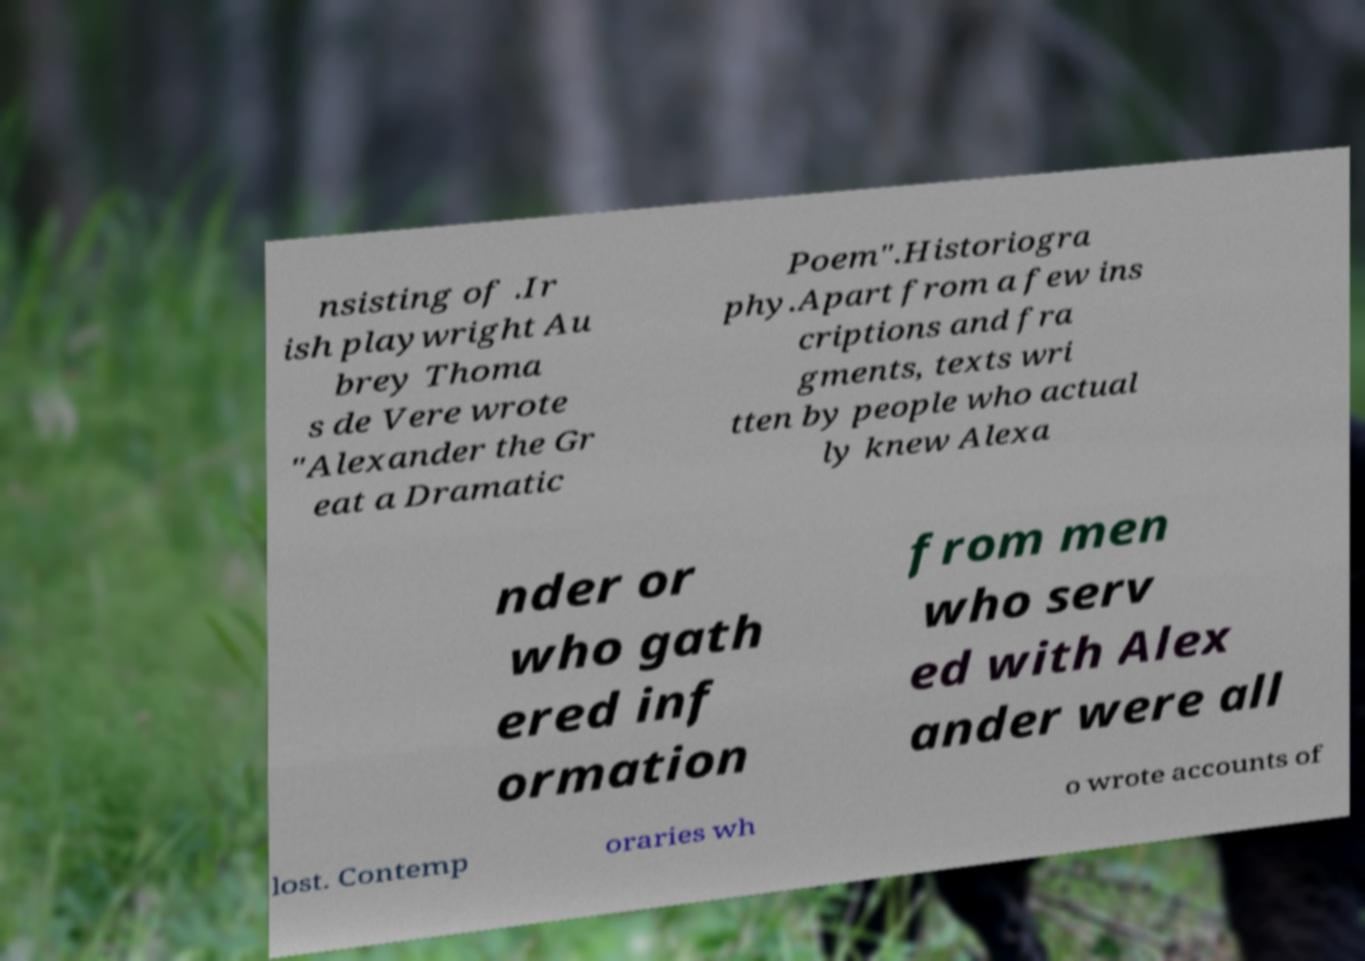Can you accurately transcribe the text from the provided image for me? nsisting of .Ir ish playwright Au brey Thoma s de Vere wrote "Alexander the Gr eat a Dramatic Poem".Historiogra phy.Apart from a few ins criptions and fra gments, texts wri tten by people who actual ly knew Alexa nder or who gath ered inf ormation from men who serv ed with Alex ander were all lost. Contemp oraries wh o wrote accounts of 